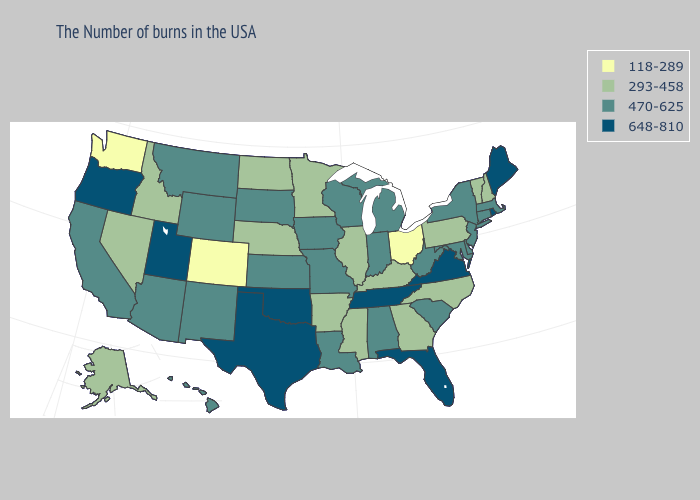What is the lowest value in the USA?
Short answer required. 118-289. What is the lowest value in the USA?
Quick response, please. 118-289. Name the states that have a value in the range 293-458?
Write a very short answer. New Hampshire, Vermont, Pennsylvania, North Carolina, Georgia, Kentucky, Illinois, Mississippi, Arkansas, Minnesota, Nebraska, North Dakota, Idaho, Nevada, Alaska. Does Pennsylvania have a lower value than New Hampshire?
Give a very brief answer. No. Does Arizona have the highest value in the USA?
Be succinct. No. Does the map have missing data?
Keep it brief. No. What is the value of Delaware?
Concise answer only. 470-625. Does New Hampshire have a lower value than Minnesota?
Keep it brief. No. Is the legend a continuous bar?
Quick response, please. No. Does Tennessee have the same value as Texas?
Keep it brief. Yes. What is the highest value in the Northeast ?
Be succinct. 648-810. Name the states that have a value in the range 118-289?
Answer briefly. Ohio, Colorado, Washington. What is the value of New Hampshire?
Short answer required. 293-458. Among the states that border New Jersey , which have the lowest value?
Short answer required. Pennsylvania. Name the states that have a value in the range 470-625?
Write a very short answer. Massachusetts, Connecticut, New York, New Jersey, Delaware, Maryland, South Carolina, West Virginia, Michigan, Indiana, Alabama, Wisconsin, Louisiana, Missouri, Iowa, Kansas, South Dakota, Wyoming, New Mexico, Montana, Arizona, California, Hawaii. 